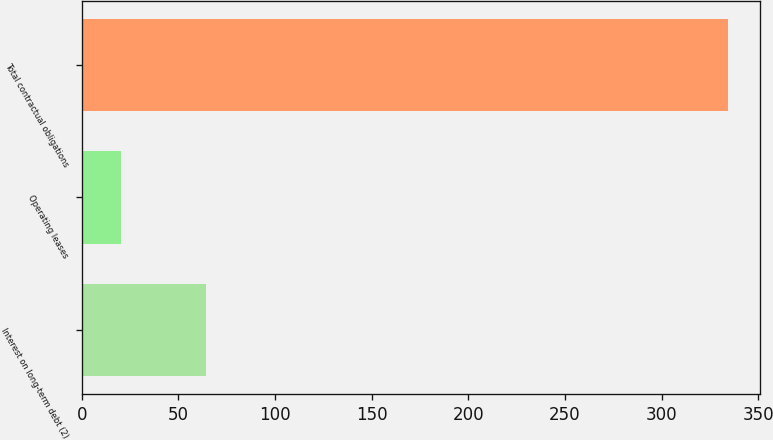<chart> <loc_0><loc_0><loc_500><loc_500><bar_chart><fcel>Interest on long-term debt (2)<fcel>Operating leases<fcel>Total contractual obligations<nl><fcel>64.1<fcel>20.1<fcel>334.2<nl></chart> 